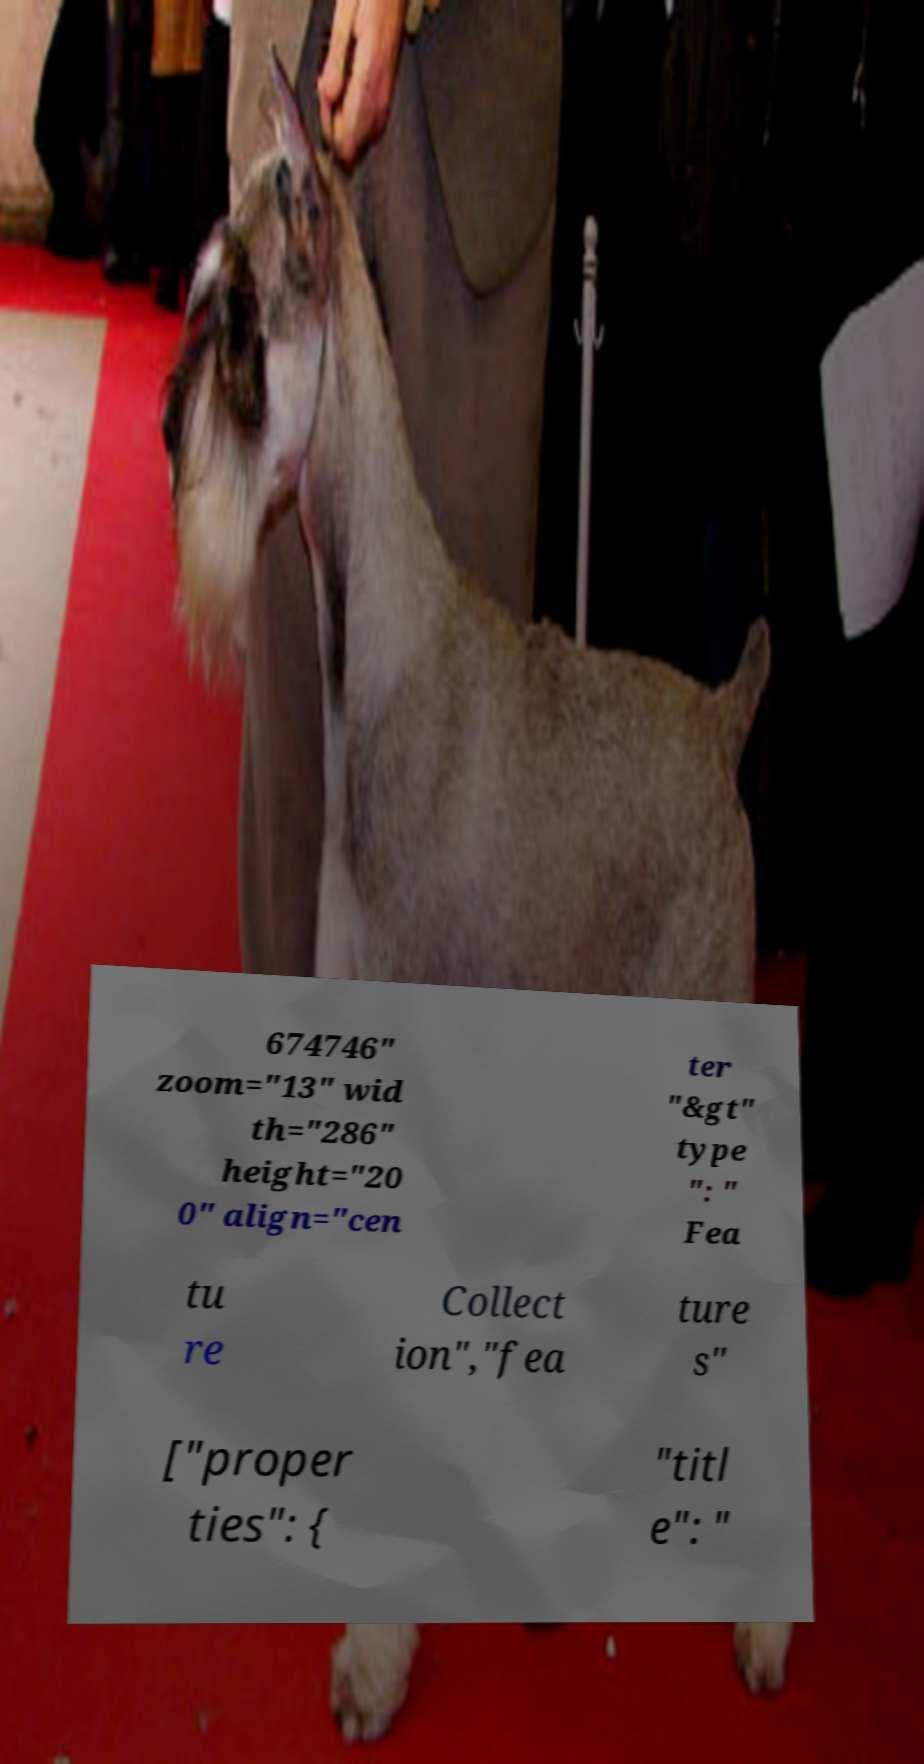Could you assist in decoding the text presented in this image and type it out clearly? 674746" zoom="13" wid th="286" height="20 0" align="cen ter "&gt" type ": " Fea tu re Collect ion","fea ture s" ["proper ties": { "titl e": " 